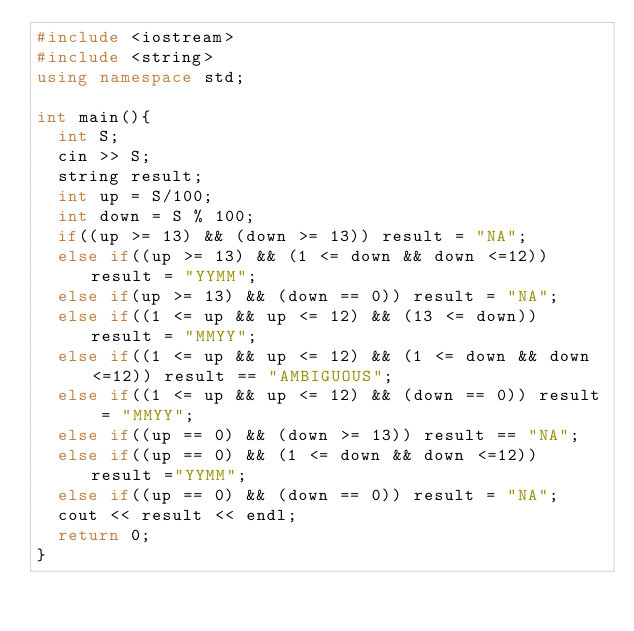Convert code to text. <code><loc_0><loc_0><loc_500><loc_500><_C++_>#include <iostream>
#include <string>
using namespace std;

int main(){
  int S;
  cin >> S;
  string result;
  int up = S/100;
  int down = S % 100;
  if((up >= 13) && (down >= 13)) result = "NA";
  else if((up >= 13) && (1 <= down && down <=12)) result = "YYMM";
  else if(up >= 13) && (down == 0)) result = "NA";
  else if((1 <= up && up <= 12) && (13 <= down)) result = "MMYY";
  else if((1 <= up && up <= 12) && (1 <= down && down <=12)) result == "AMBIGUOUS";
  else if((1 <= up && up <= 12) && (down == 0)) result = "MMYY";
  else if((up == 0) && (down >= 13)) result == "NA";
  else if((up == 0) && (1 <= down && down <=12)) result ="YYMM";
  else if((up == 0) && (down == 0)) result = "NA";
  cout << result << endl;
  return 0;
}</code> 